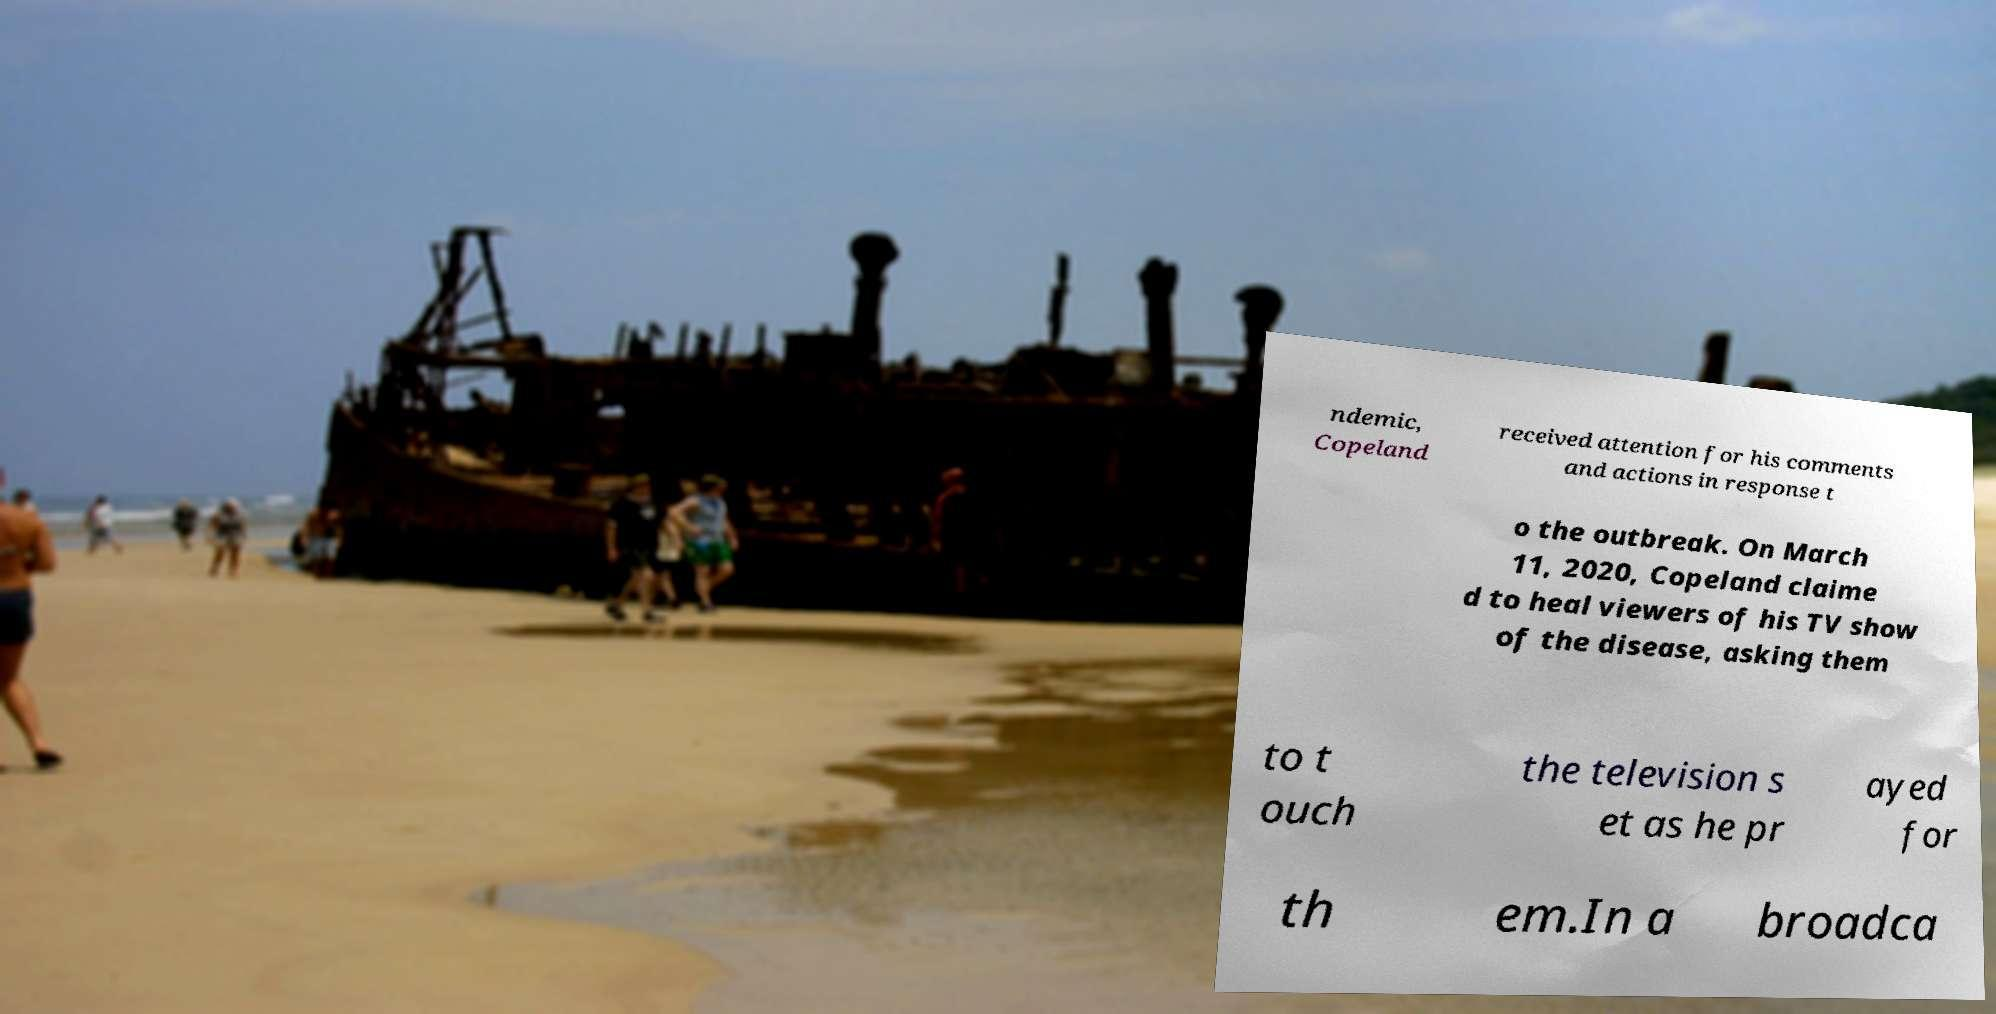What messages or text are displayed in this image? I need them in a readable, typed format. ndemic, Copeland received attention for his comments and actions in response t o the outbreak. On March 11, 2020, Copeland claime d to heal viewers of his TV show of the disease, asking them to t ouch the television s et as he pr ayed for th em.In a broadca 